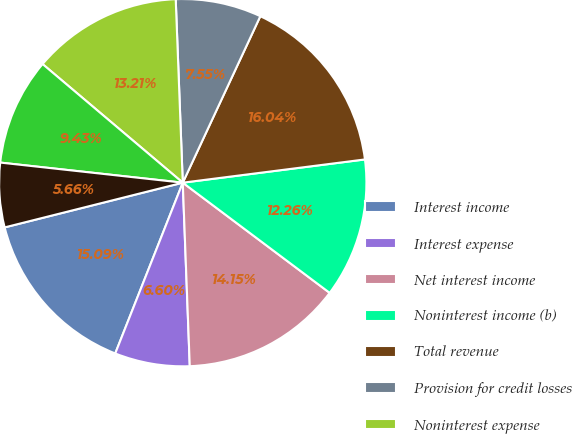Convert chart. <chart><loc_0><loc_0><loc_500><loc_500><pie_chart><fcel>Interest income<fcel>Interest expense<fcel>Net interest income<fcel>Noninterest income (b)<fcel>Total revenue<fcel>Provision for credit losses<fcel>Noninterest expense<fcel>Income from continuing<fcel>Income taxes<nl><fcel>15.09%<fcel>6.6%<fcel>14.15%<fcel>12.26%<fcel>16.04%<fcel>7.55%<fcel>13.21%<fcel>9.43%<fcel>5.66%<nl></chart> 